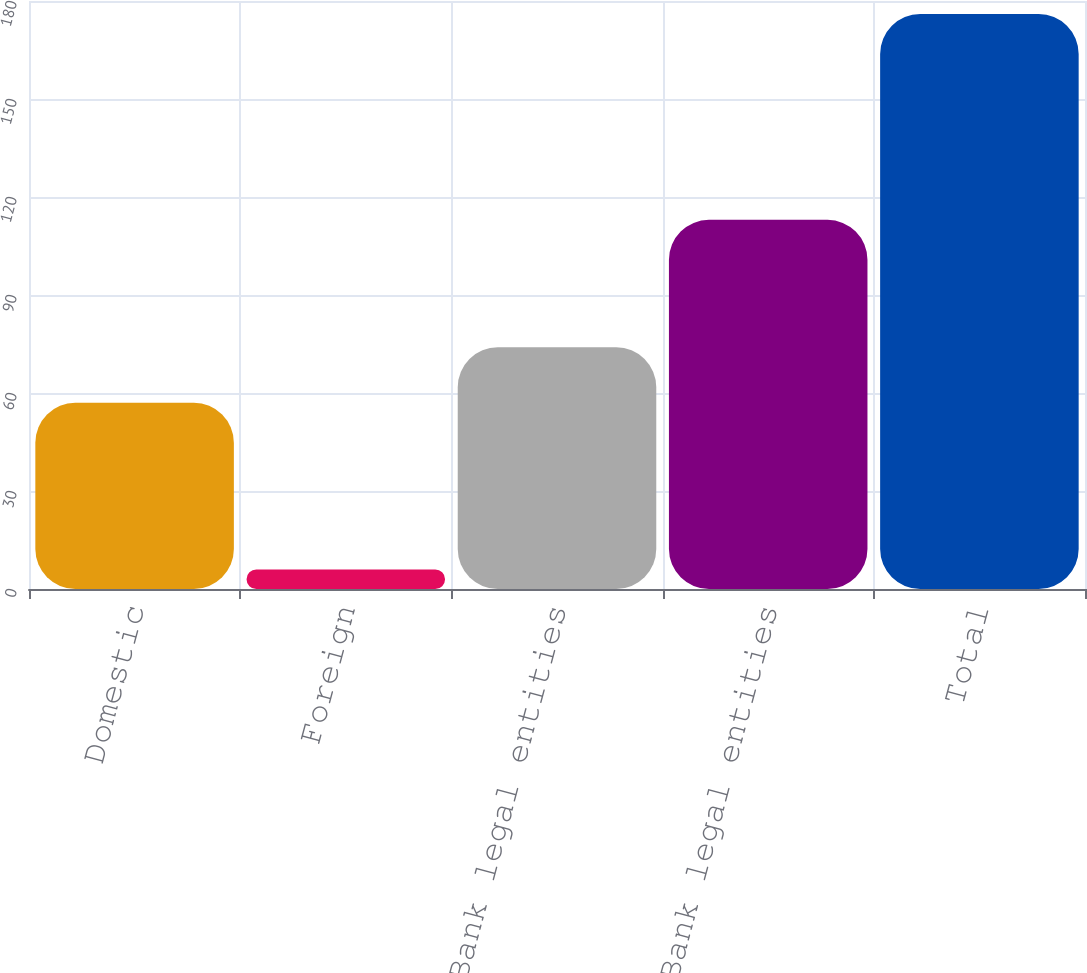Convert chart to OTSL. <chart><loc_0><loc_0><loc_500><loc_500><bar_chart><fcel>Domestic<fcel>Foreign<fcel>Total Bank legal entities<fcel>Total Non-Bank legal entities<fcel>Total<nl><fcel>57<fcel>6<fcel>74<fcel>113<fcel>176<nl></chart> 